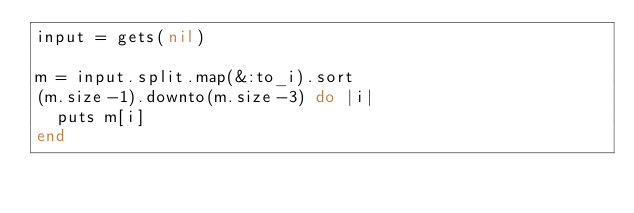Convert code to text. <code><loc_0><loc_0><loc_500><loc_500><_Ruby_>input = gets(nil)

m = input.split.map(&:to_i).sort
(m.size-1).downto(m.size-3) do |i|
  puts m[i]
end</code> 